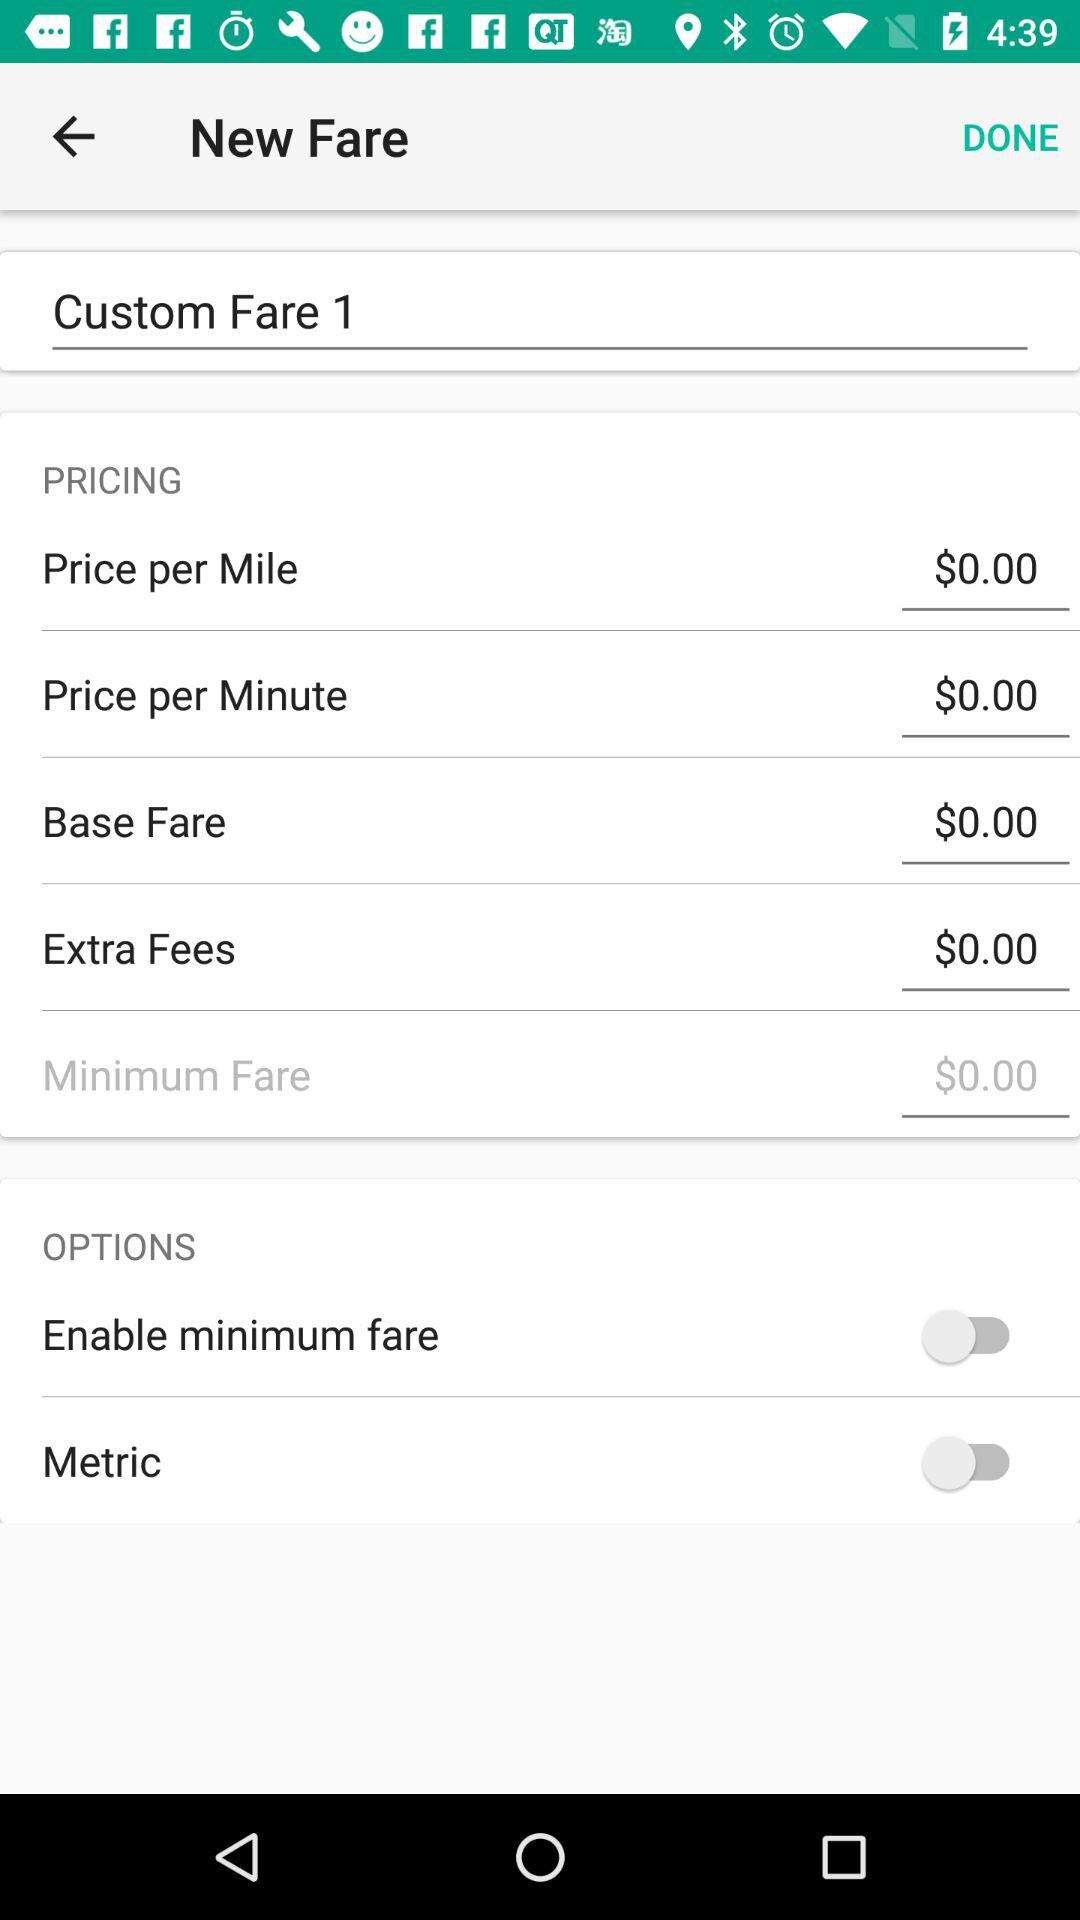How much is the base fare? The base fare is $0.00. 